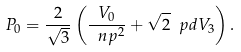<formula> <loc_0><loc_0><loc_500><loc_500>P _ { 0 } = \frac { 2 } { \sqrt { 3 } } \left ( \frac { V _ { 0 } } { \ n p ^ { 2 } } + \sqrt { 2 } \ p d V _ { 3 } \right ) .</formula> 